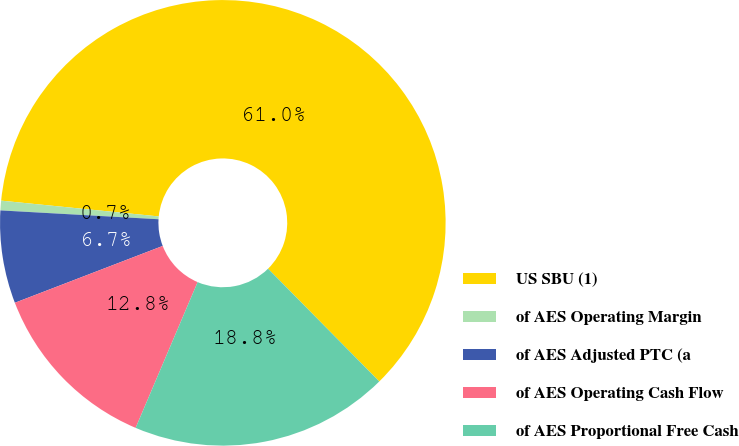Convert chart to OTSL. <chart><loc_0><loc_0><loc_500><loc_500><pie_chart><fcel>US SBU (1)<fcel>of AES Operating Margin<fcel>of AES Adjusted PTC (a<fcel>of AES Operating Cash Flow<fcel>of AES Proportional Free Cash<nl><fcel>61.02%<fcel>0.7%<fcel>6.73%<fcel>12.76%<fcel>18.79%<nl></chart> 